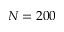Convert formula to latex. <formula><loc_0><loc_0><loc_500><loc_500>N = 2 0 0</formula> 